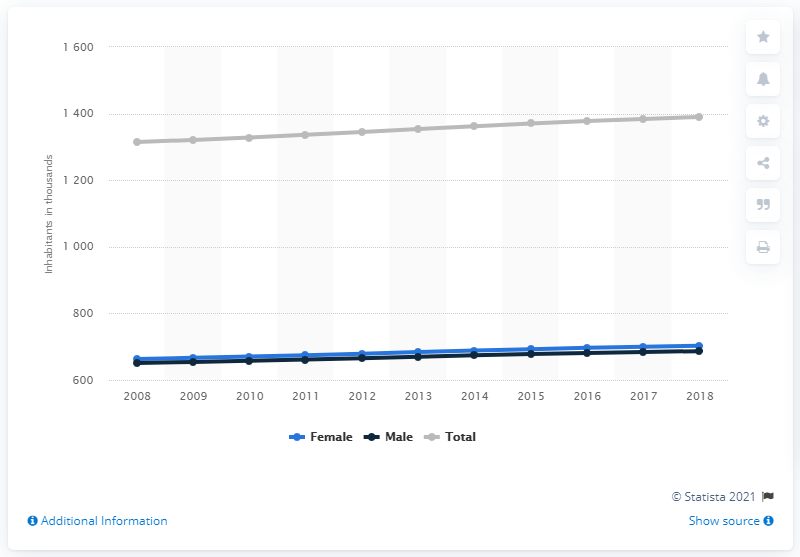Specify some key components in this picture. The population of Trinidad and Tobago began to increase in 2008. 